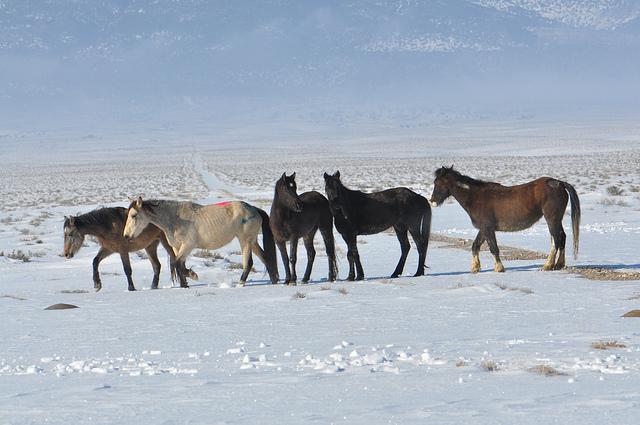How many horses are in the picture?
Give a very brief answer. 5. How many horses can be seen?
Give a very brief answer. 5. How many people are depicted on the cover of the book?
Give a very brief answer. 0. 